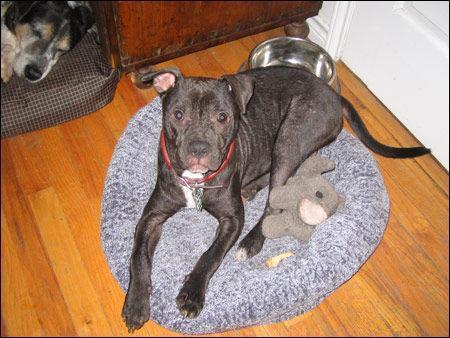How many dogs are sleeping?
Give a very brief answer. 1. How many dogs are in the picture?
Give a very brief answer. 2. How many red chairs are there?
Give a very brief answer. 0. 